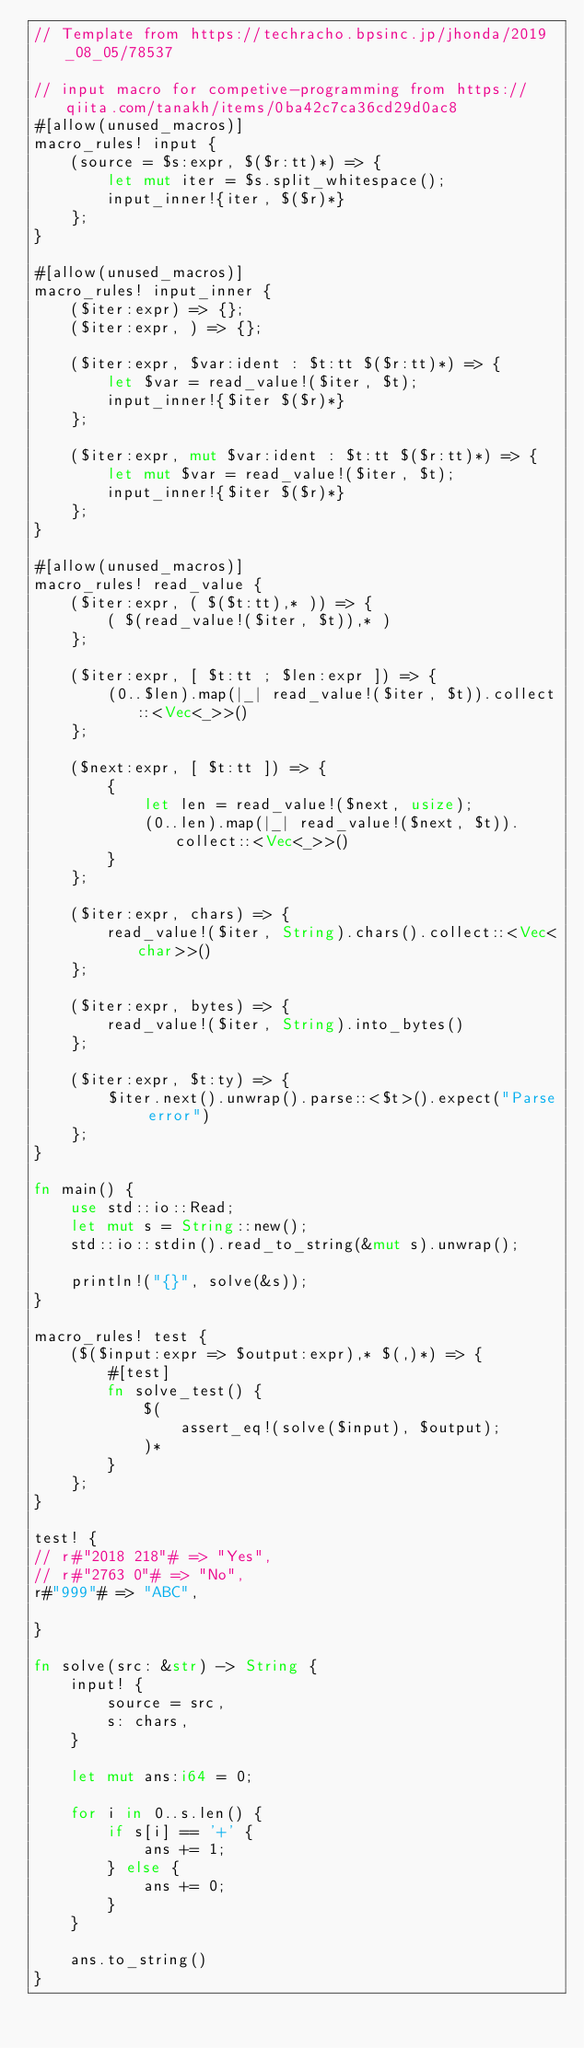Convert code to text. <code><loc_0><loc_0><loc_500><loc_500><_Rust_>// Template from https://techracho.bpsinc.jp/jhonda/2019_08_05/78537

// input macro for competive-programming from https://qiita.com/tanakh/items/0ba42c7ca36cd29d0ac8
#[allow(unused_macros)]
macro_rules! input {
    (source = $s:expr, $($r:tt)*) => {
        let mut iter = $s.split_whitespace();
        input_inner!{iter, $($r)*}
    };
}

#[allow(unused_macros)]
macro_rules! input_inner {
    ($iter:expr) => {};
    ($iter:expr, ) => {};

    ($iter:expr, $var:ident : $t:tt $($r:tt)*) => {
        let $var = read_value!($iter, $t);
        input_inner!{$iter $($r)*}
    };

    ($iter:expr, mut $var:ident : $t:tt $($r:tt)*) => {
        let mut $var = read_value!($iter, $t);
        input_inner!{$iter $($r)*}
    };
}

#[allow(unused_macros)]
macro_rules! read_value {
    ($iter:expr, ( $($t:tt),* )) => {
        ( $(read_value!($iter, $t)),* )
    };

    ($iter:expr, [ $t:tt ; $len:expr ]) => {
        (0..$len).map(|_| read_value!($iter, $t)).collect::<Vec<_>>()
    };

    ($next:expr, [ $t:tt ]) => {
        {
            let len = read_value!($next, usize);
            (0..len).map(|_| read_value!($next, $t)).collect::<Vec<_>>()
        }
    };

    ($iter:expr, chars) => {
        read_value!($iter, String).chars().collect::<Vec<char>>()
    };

    ($iter:expr, bytes) => {
        read_value!($iter, String).into_bytes()
    };

    ($iter:expr, $t:ty) => {
        $iter.next().unwrap().parse::<$t>().expect("Parse error")
    };
}

fn main() {
    use std::io::Read;
    let mut s = String::new();
    std::io::stdin().read_to_string(&mut s).unwrap();

    println!("{}", solve(&s));
}

macro_rules! test {
    ($($input:expr => $output:expr),* $(,)*) => {
        #[test]
        fn solve_test() {
            $(
                assert_eq!(solve($input), $output);
            )*
        }
    };
}

test! {
// r#"2018 218"# => "Yes",
// r#"2763 0"# => "No",
r#"999"# => "ABC",

}

fn solve(src: &str) -> String {
    input! {
        source = src,
        s: chars,
    }

    let mut ans:i64 = 0;

    for i in 0..s.len() {
        if s[i] == '+' {
            ans += 1;
        } else {
            ans += 0;
        }
    }

    ans.to_string()
}</code> 